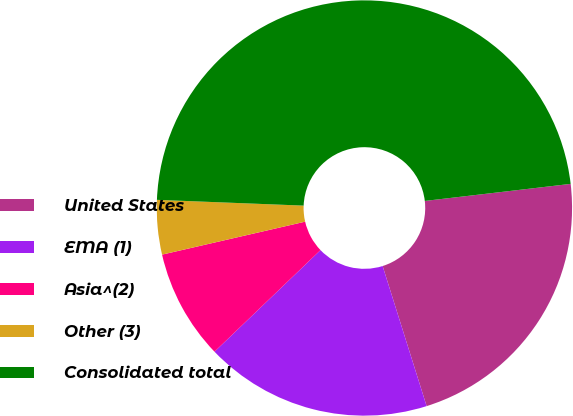Convert chart. <chart><loc_0><loc_0><loc_500><loc_500><pie_chart><fcel>United States<fcel>EMA (1)<fcel>Asia^(2)<fcel>Other (3)<fcel>Consolidated total<nl><fcel>22.01%<fcel>17.68%<fcel>8.56%<fcel>4.23%<fcel>47.52%<nl></chart> 